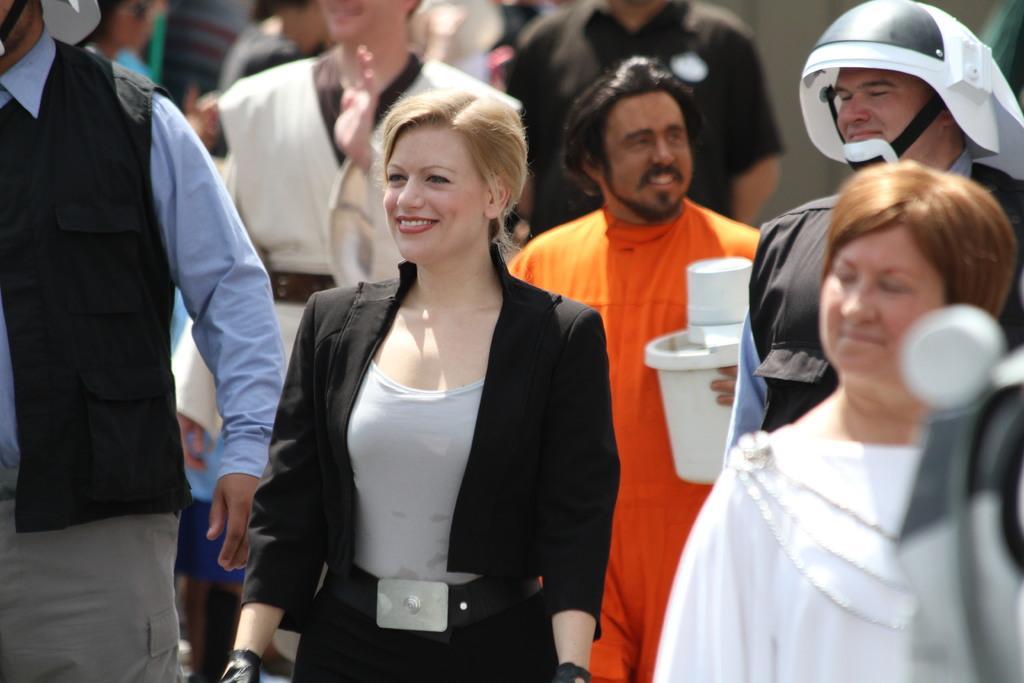In one or two sentences, can you explain what this image depicts? In the middle of the image there is a lady with black jacket and grey t-shirt is standing and she is smiling. Behind her there are many people standing. 